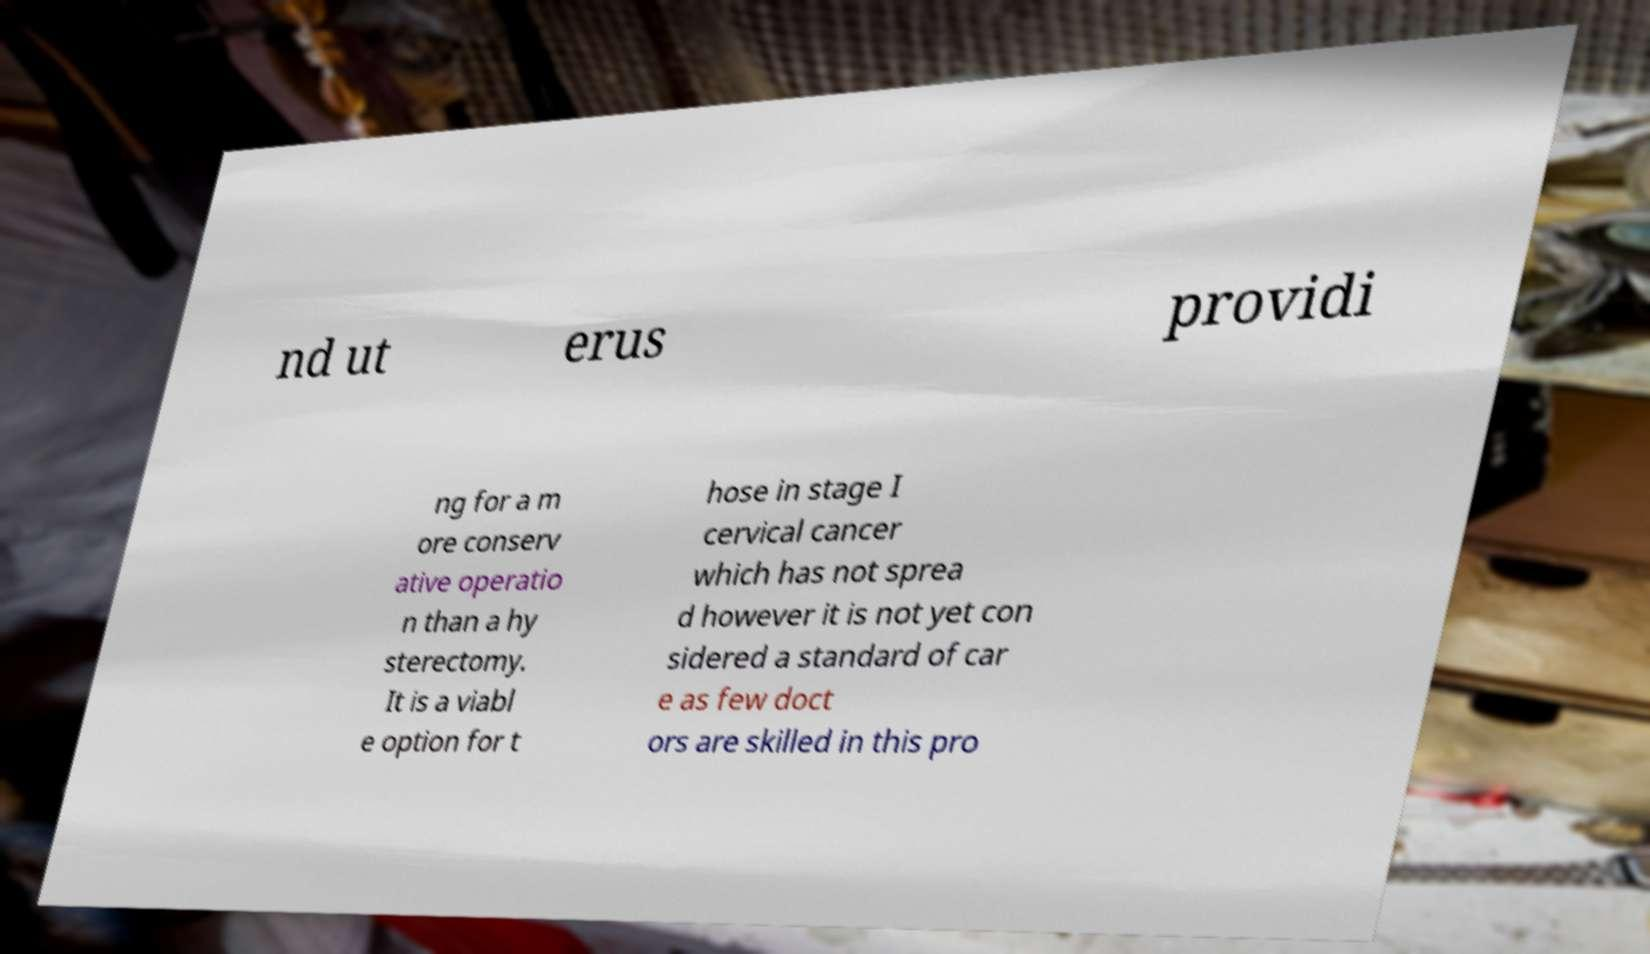Can you read and provide the text displayed in the image?This photo seems to have some interesting text. Can you extract and type it out for me? nd ut erus providi ng for a m ore conserv ative operatio n than a hy sterectomy. It is a viabl e option for t hose in stage I cervical cancer which has not sprea d however it is not yet con sidered a standard of car e as few doct ors are skilled in this pro 